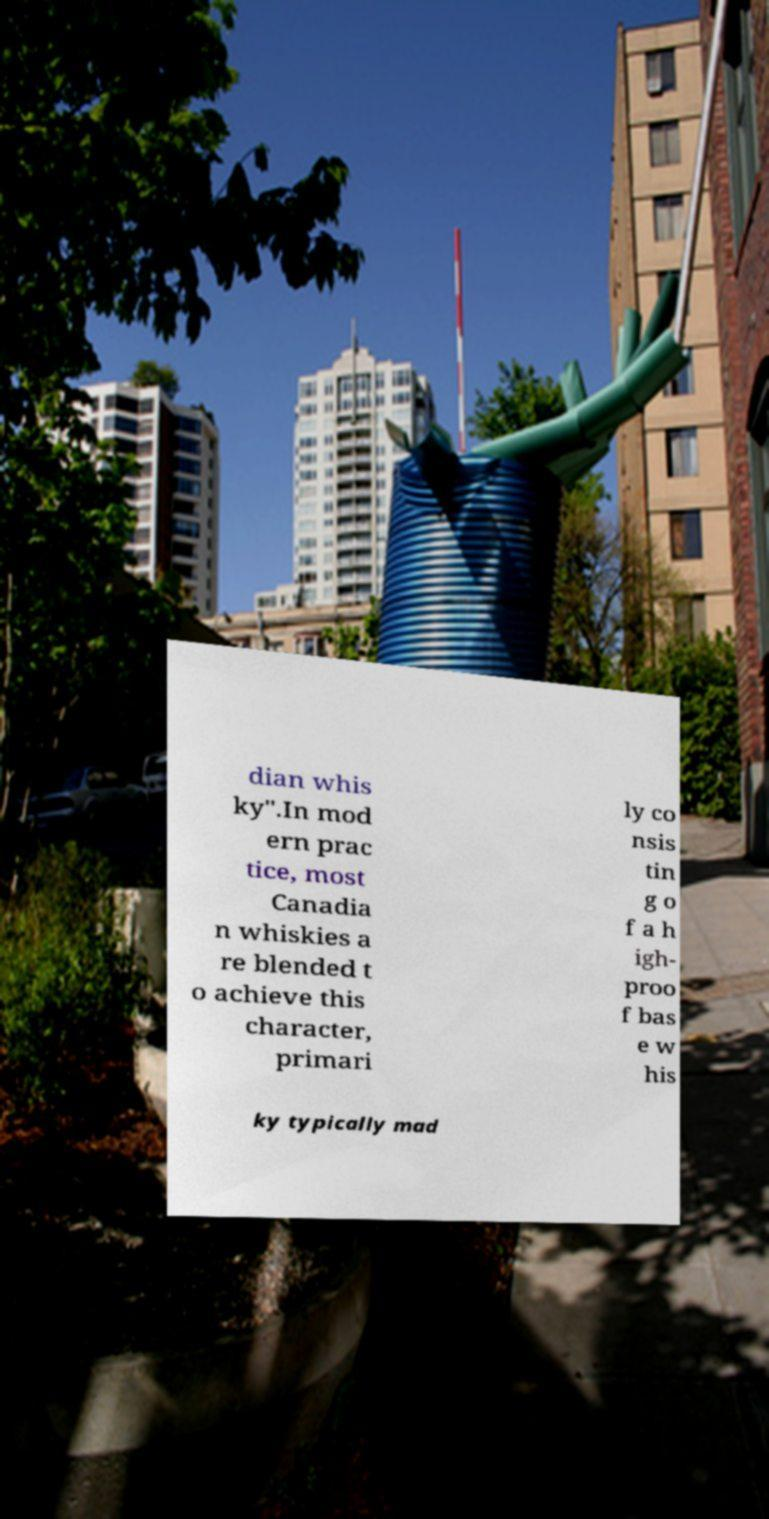For documentation purposes, I need the text within this image transcribed. Could you provide that? dian whis ky".In mod ern prac tice, most Canadia n whiskies a re blended t o achieve this character, primari ly co nsis tin g o f a h igh- proo f bas e w his ky typically mad 